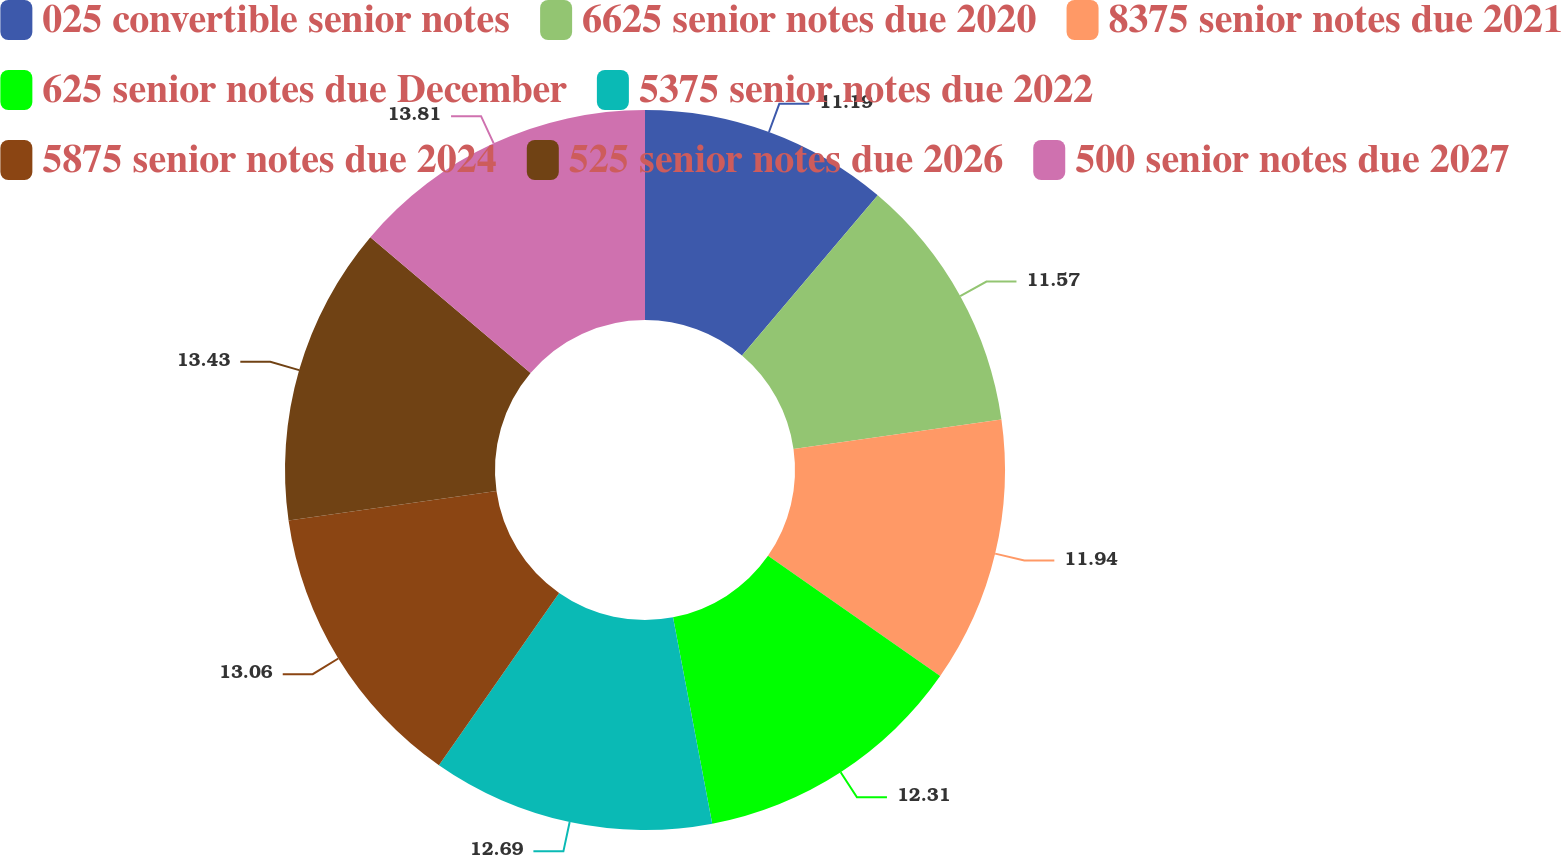<chart> <loc_0><loc_0><loc_500><loc_500><pie_chart><fcel>025 convertible senior notes<fcel>6625 senior notes due 2020<fcel>8375 senior notes due 2021<fcel>625 senior notes due December<fcel>5375 senior notes due 2022<fcel>5875 senior notes due 2024<fcel>525 senior notes due 2026<fcel>500 senior notes due 2027<nl><fcel>11.19%<fcel>11.57%<fcel>11.94%<fcel>12.31%<fcel>12.69%<fcel>13.06%<fcel>13.43%<fcel>13.81%<nl></chart> 